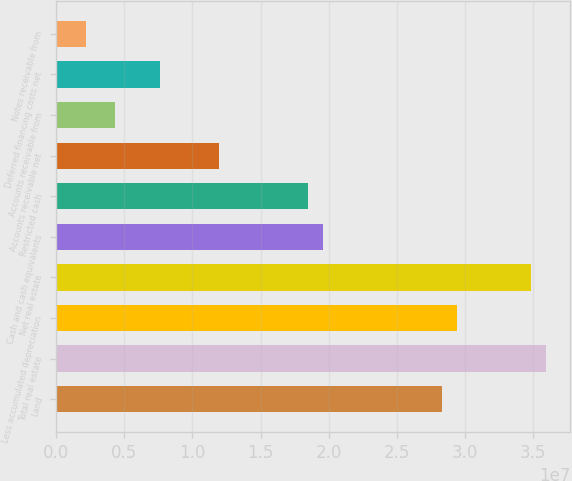Convert chart. <chart><loc_0><loc_0><loc_500><loc_500><bar_chart><fcel>Land<fcel>Total real estate<fcel>Less accumulated depreciation<fcel>Net real estate<fcel>Cash and cash equivalents<fcel>Restricted cash<fcel>Accounts receivable net<fcel>Accounts receivable from<fcel>Deferred financing costs net<fcel>Notes receivable from<nl><fcel>2.82994e+07<fcel>3.59181e+07<fcel>2.93878e+07<fcel>3.48297e+07<fcel>1.95922e+07<fcel>1.85038e+07<fcel>1.19735e+07<fcel>4.35473e+06<fcel>7.61991e+06<fcel>2.17795e+06<nl></chart> 